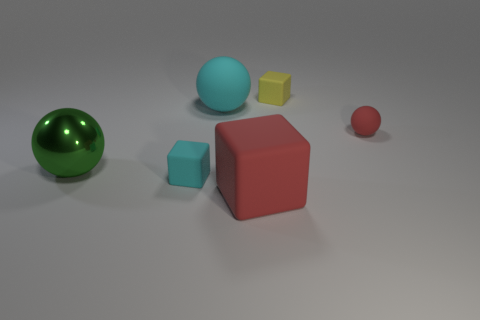Is the number of cyan balls that are in front of the big metallic thing greater than the number of tiny red matte spheres?
Offer a very short reply. No. Are any green things visible?
Provide a succinct answer. Yes. What number of cyan objects have the same size as the red ball?
Ensure brevity in your answer.  1. Are there more small yellow blocks to the left of the big red matte object than tiny yellow matte cubes that are to the right of the tiny cyan matte block?
Provide a succinct answer. No. There is a cyan object that is the same size as the red block; what material is it?
Give a very brief answer. Rubber. What shape is the yellow matte thing?
Offer a terse response. Cube. What number of blue things are either metal balls or matte blocks?
Your response must be concise. 0. The cyan ball that is the same material as the big red thing is what size?
Your answer should be compact. Large. Do the big ball in front of the large cyan thing and the tiny ball that is right of the yellow thing have the same material?
Give a very brief answer. No. What number of cubes are either big purple objects or tiny yellow things?
Keep it short and to the point. 1. 